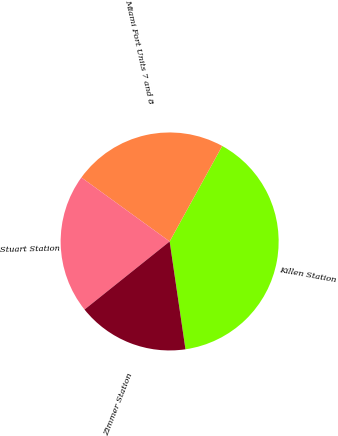Convert chart to OTSL. <chart><loc_0><loc_0><loc_500><loc_500><pie_chart><fcel>Killen Station<fcel>Miami Fort Units 7 and 8<fcel>Stuart Station<fcel>Zimmer Station<nl><fcel>39.67%<fcel>23.03%<fcel>20.72%<fcel>16.58%<nl></chart> 